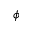Convert formula to latex. <formula><loc_0><loc_0><loc_500><loc_500>\phi</formula> 